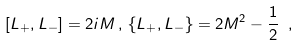<formula> <loc_0><loc_0><loc_500><loc_500>\left [ L _ { + } , L _ { - } \right ] = 2 i M \, , \, \left \{ L _ { + } , L _ { - } \right \} = 2 M ^ { 2 } - \frac { 1 } { 2 } \ ,</formula> 